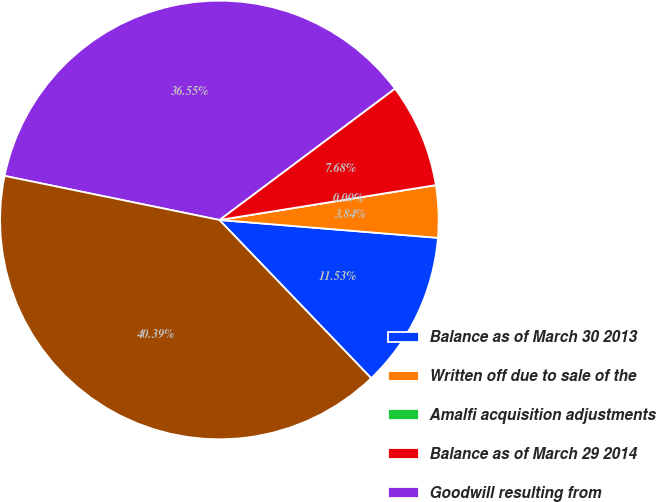Convert chart. <chart><loc_0><loc_0><loc_500><loc_500><pie_chart><fcel>Balance as of March 30 2013<fcel>Written off due to sale of the<fcel>Amalfi acquisition adjustments<fcel>Balance as of March 29 2014<fcel>Goodwill resulting from<fcel>Balance as of March 28 2015<nl><fcel>11.53%<fcel>3.84%<fcel>0.0%<fcel>7.68%<fcel>36.55%<fcel>40.39%<nl></chart> 